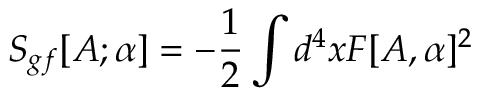Convert formula to latex. <formula><loc_0><loc_0><loc_500><loc_500>S _ { g f } [ A ; \alpha ] = - \frac { 1 } { 2 } \int d ^ { 4 } x F [ A , \alpha ] ^ { 2 }</formula> 